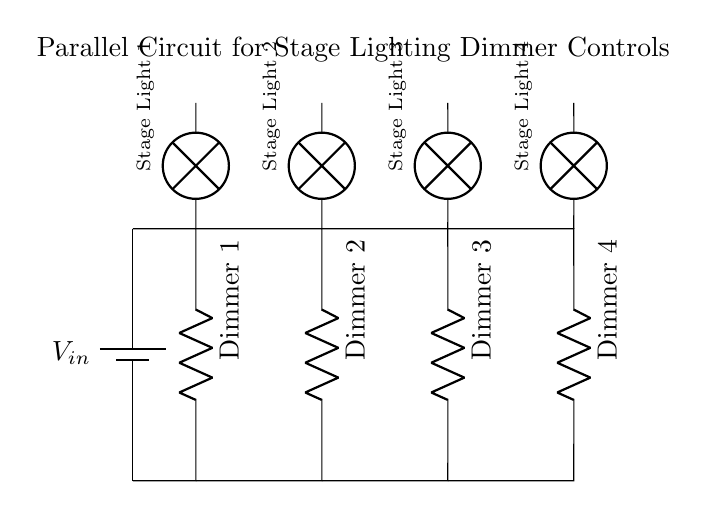What is the input voltage for the circuit? The circuit diagram does not specify a numerical value for the input voltage, but it is labeled as Vin, suggesting that it is the input voltage supplied to the dimmers.
Answer: Vin How many dimmers are present in the circuit? By counting the components labeled as "Dimmer," we find that there are four distinct dimmer components connected in parallel.
Answer: 4 Which lamps correspond to the dimmers? Each lamp is placed directly above its respective dimmer; thus, Lamp 1 corresponds to Dimmer 1, Lamp 2 to Dimmer 2, Lamp 3 to Dimmer 3, and Lamp 4 to Dimmer 4.
Answer: Lamp 1, Lamp 2, Lamp 3, Lamp 4 What type of circuit is shown in the diagram? The circuit shows a parallel connection because all components are connected across the same two points; this allows for individual control of each lamp and dimmer without affecting the others.
Answer: Parallel What is the purpose of the dimmers in this circuit? Dimmers are used to control the brightness of the stage lights by adjusting the resistance in the circuit, which ultimately modulates the current passing through the lamps.
Answer: Control brightness 